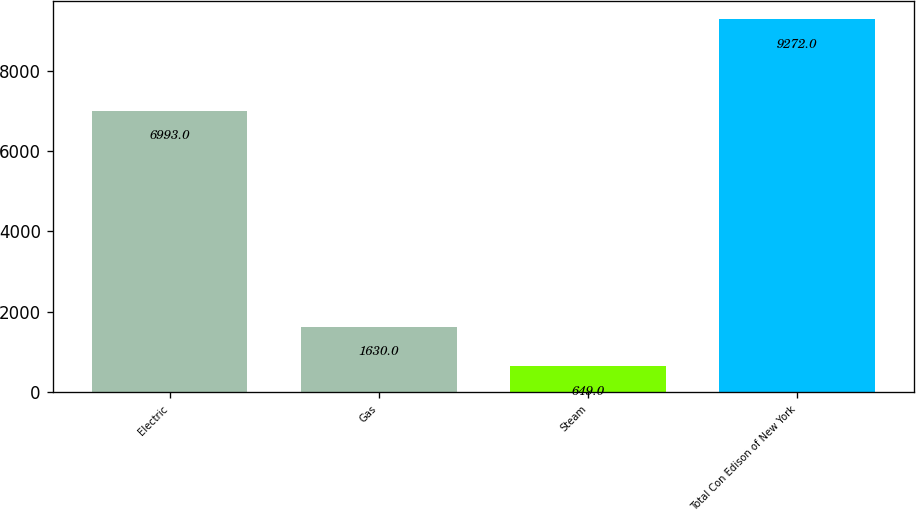Convert chart to OTSL. <chart><loc_0><loc_0><loc_500><loc_500><bar_chart><fcel>Electric<fcel>Gas<fcel>Steam<fcel>Total Con Edison of New York<nl><fcel>6993<fcel>1630<fcel>649<fcel>9272<nl></chart> 